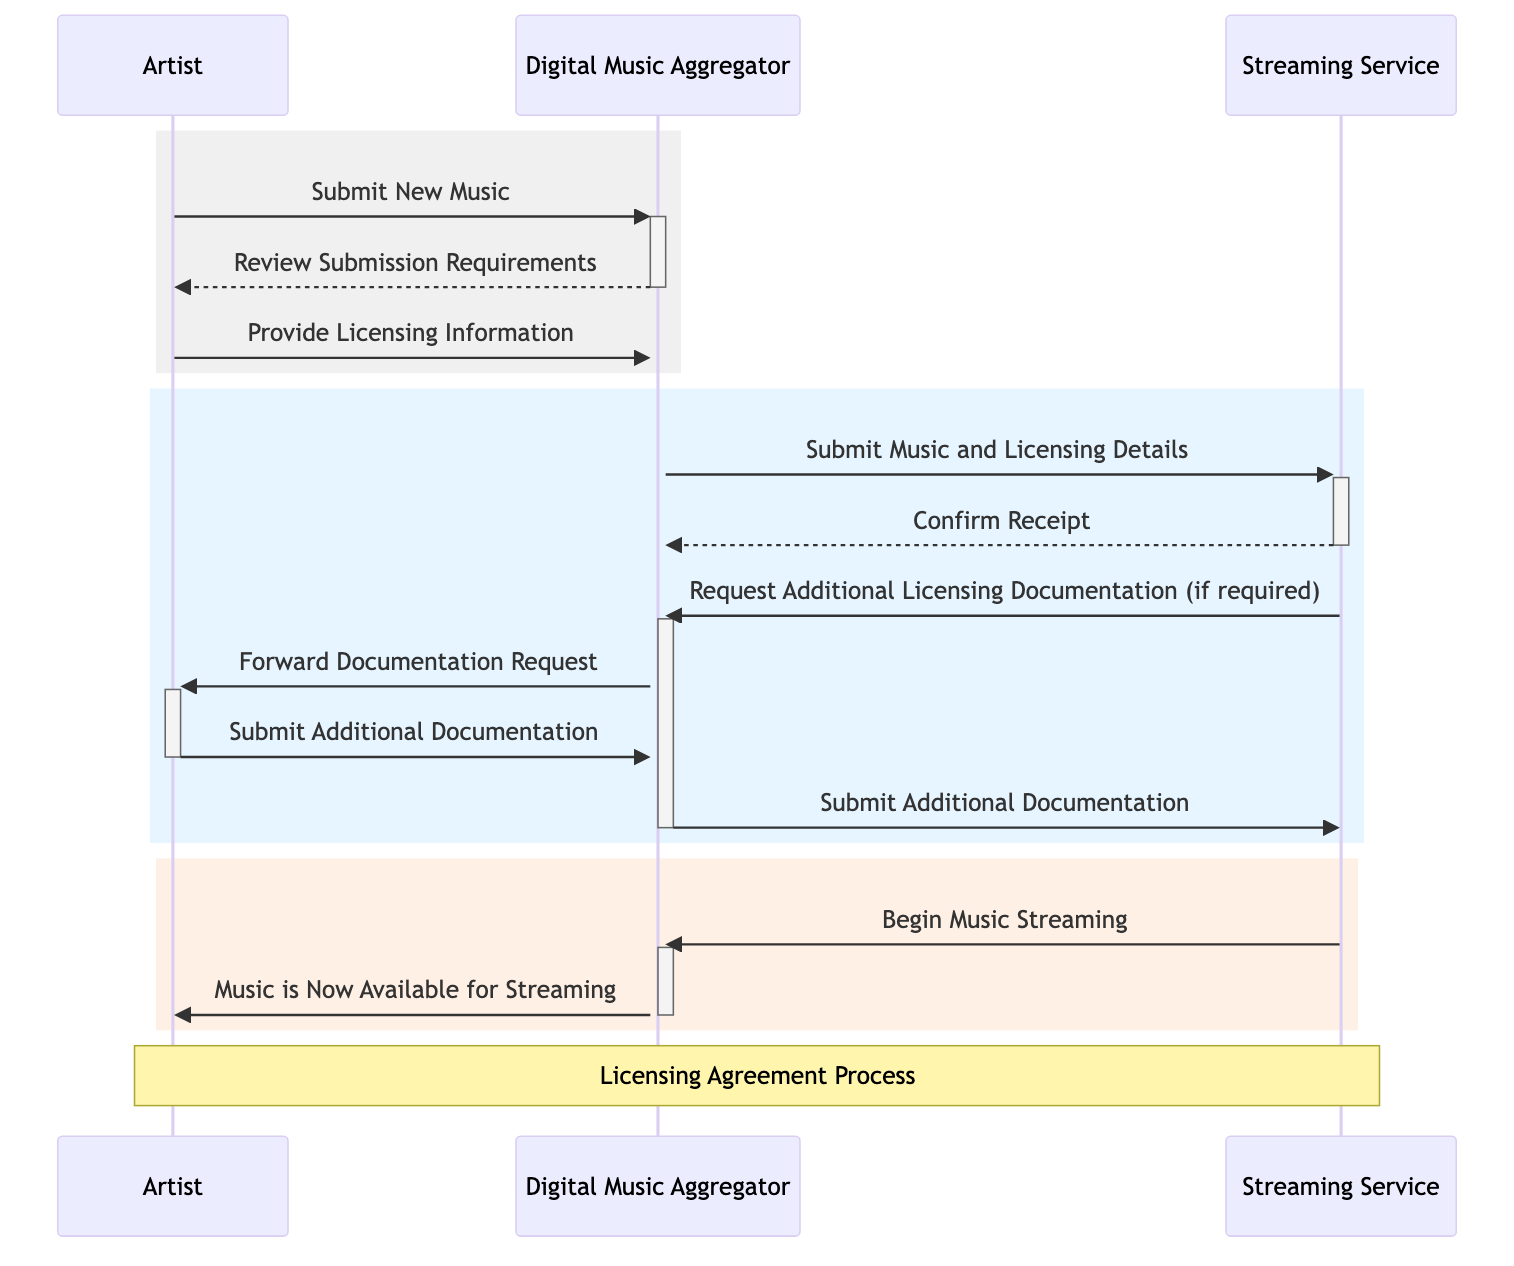What is the first message sent in the sequence? The first message in the sequence is sent from the Artist to the Digital Music Aggregator, indicating the submission of new music. This is clearly indicated as the first interaction in the first rectangular section of the diagram.
Answer: Submit New Music How many main participants are in the diagram? The diagram shows three main participants: the Artist, the Digital Music Aggregator, and the Streaming Service. This can be counted from the "Actors" section of the provided data.
Answer: Three What action takes place after the Digital Music Aggregator submits music and licensing details? After the Digital Music Aggregator submits music and licensing details, the Streaming Service confirms receipt of those details. This sequence is straightforward, as it follows directly from the submission message in the flow.
Answer: Confirm Receipt Which participant forwards the documentation request to the Artist? The Digital Music Aggregator is the participant that forwards the documentation request to the Artist, as indicated in the message sequence following the request made by the Streaming Service.
Answer: Digital Music Aggregator What message indicates the final action in the flow? The final action in the flow is indicated by the message sent from the Streaming Service to the Digital Music Aggregator stating "Begin Music Streaming." This is the last communication in the sequence, leading to the final outcome.
Answer: Begin Music Streaming What is the last message received by the Artist? The last message received by the Artist is "Music is Now Available for Streaming." This message comes after the Streaming Service initiates the music streaming process, and is the concluding interaction for the Artist in the diagram.
Answer: Music is Now Available for Streaming What is the purpose of the note in the diagram? The note in the diagram serves to clarify that the interactions between the participants pertain specifically to the Licensing Agreement Process. It is an annotation that provides context to the main actions depicted in the sequence.
Answer: Licensing Agreement Process How many requests for additional documentation occur, if necessary? The request for additional documentation occurs once when the Streaming Service sends a message that explicitly states the need for "Additional Licensing Documentation." This is based on the sequence of communications where such a request is made by the Streaming Service.
Answer: One 